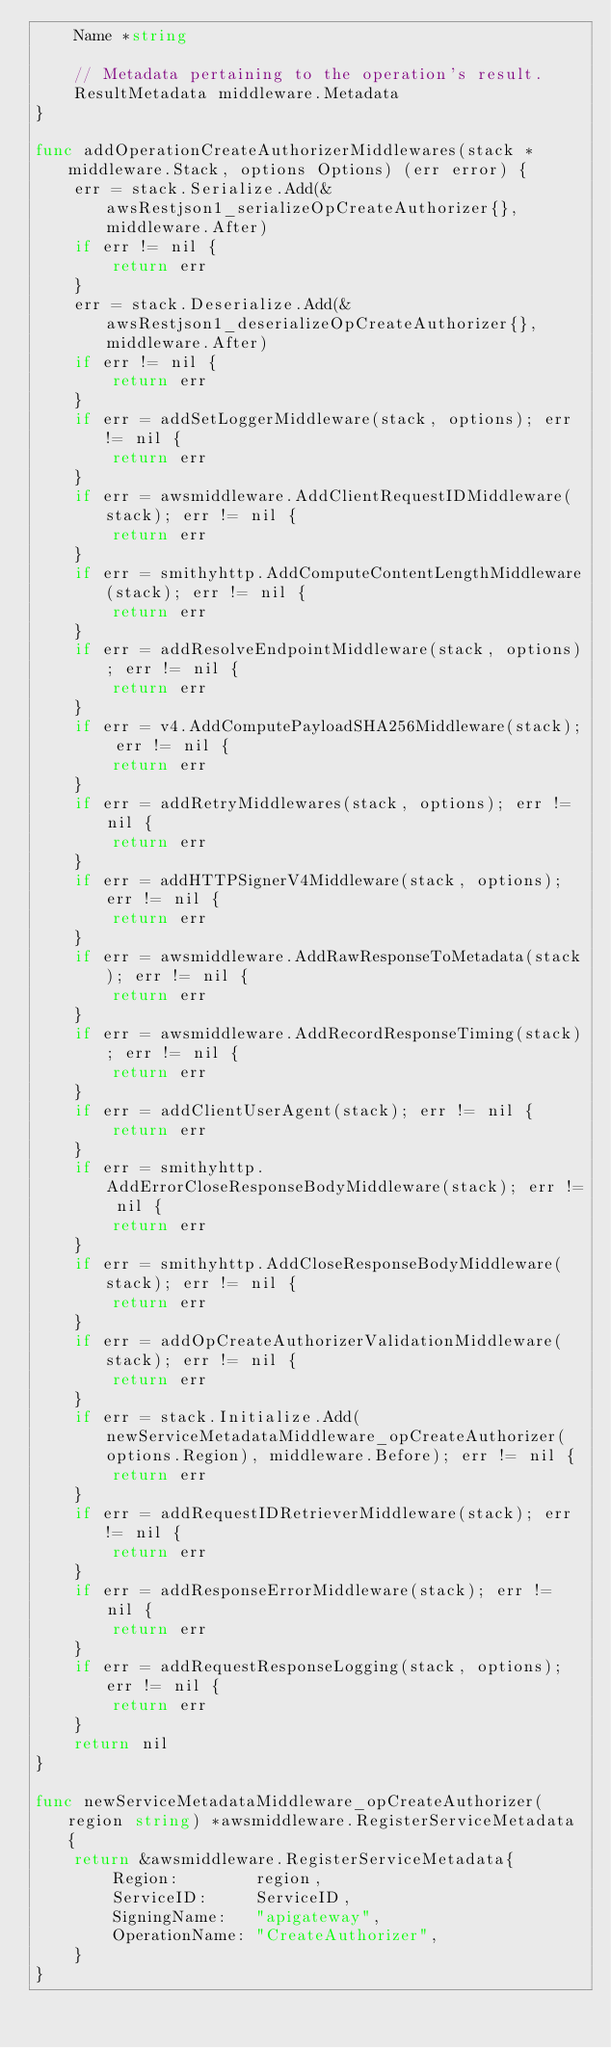Convert code to text. <code><loc_0><loc_0><loc_500><loc_500><_Go_>	Name *string

	// Metadata pertaining to the operation's result.
	ResultMetadata middleware.Metadata
}

func addOperationCreateAuthorizerMiddlewares(stack *middleware.Stack, options Options) (err error) {
	err = stack.Serialize.Add(&awsRestjson1_serializeOpCreateAuthorizer{}, middleware.After)
	if err != nil {
		return err
	}
	err = stack.Deserialize.Add(&awsRestjson1_deserializeOpCreateAuthorizer{}, middleware.After)
	if err != nil {
		return err
	}
	if err = addSetLoggerMiddleware(stack, options); err != nil {
		return err
	}
	if err = awsmiddleware.AddClientRequestIDMiddleware(stack); err != nil {
		return err
	}
	if err = smithyhttp.AddComputeContentLengthMiddleware(stack); err != nil {
		return err
	}
	if err = addResolveEndpointMiddleware(stack, options); err != nil {
		return err
	}
	if err = v4.AddComputePayloadSHA256Middleware(stack); err != nil {
		return err
	}
	if err = addRetryMiddlewares(stack, options); err != nil {
		return err
	}
	if err = addHTTPSignerV4Middleware(stack, options); err != nil {
		return err
	}
	if err = awsmiddleware.AddRawResponseToMetadata(stack); err != nil {
		return err
	}
	if err = awsmiddleware.AddRecordResponseTiming(stack); err != nil {
		return err
	}
	if err = addClientUserAgent(stack); err != nil {
		return err
	}
	if err = smithyhttp.AddErrorCloseResponseBodyMiddleware(stack); err != nil {
		return err
	}
	if err = smithyhttp.AddCloseResponseBodyMiddleware(stack); err != nil {
		return err
	}
	if err = addOpCreateAuthorizerValidationMiddleware(stack); err != nil {
		return err
	}
	if err = stack.Initialize.Add(newServiceMetadataMiddleware_opCreateAuthorizer(options.Region), middleware.Before); err != nil {
		return err
	}
	if err = addRequestIDRetrieverMiddleware(stack); err != nil {
		return err
	}
	if err = addResponseErrorMiddleware(stack); err != nil {
		return err
	}
	if err = addRequestResponseLogging(stack, options); err != nil {
		return err
	}
	return nil
}

func newServiceMetadataMiddleware_opCreateAuthorizer(region string) *awsmiddleware.RegisterServiceMetadata {
	return &awsmiddleware.RegisterServiceMetadata{
		Region:        region,
		ServiceID:     ServiceID,
		SigningName:   "apigateway",
		OperationName: "CreateAuthorizer",
	}
}
</code> 